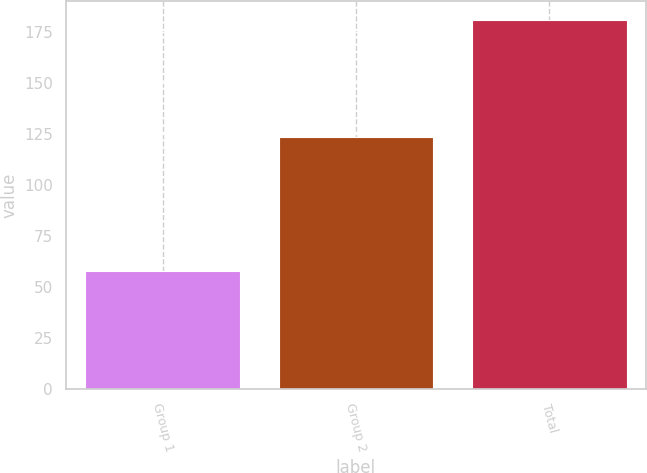Convert chart to OTSL. <chart><loc_0><loc_0><loc_500><loc_500><bar_chart><fcel>Group 1<fcel>Group 2<fcel>Total<nl><fcel>57.7<fcel>123.2<fcel>180.9<nl></chart> 